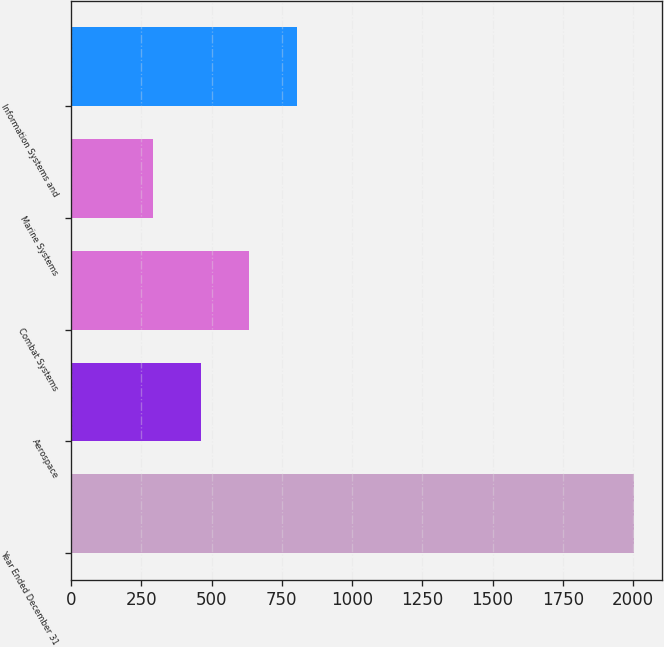Convert chart to OTSL. <chart><loc_0><loc_0><loc_500><loc_500><bar_chart><fcel>Year Ended December 31<fcel>Aerospace<fcel>Combat Systems<fcel>Marine Systems<fcel>Information Systems and<nl><fcel>2004<fcel>463.2<fcel>634.4<fcel>292<fcel>805.6<nl></chart> 